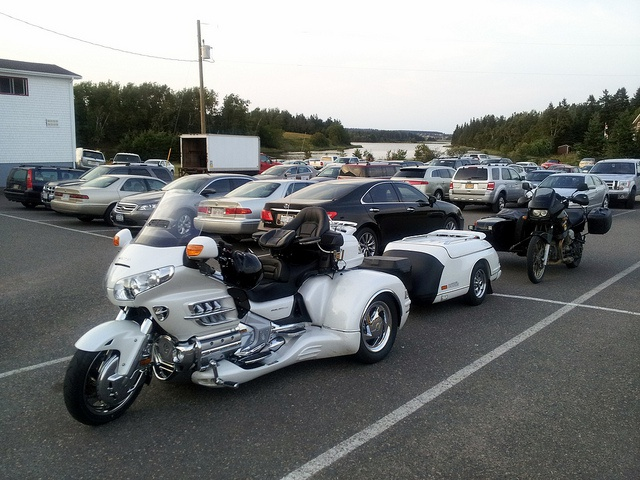Describe the objects in this image and their specific colors. I can see motorcycle in white, black, darkgray, lightgray, and gray tones, car in white, gray, black, and darkgray tones, car in white, black, gray, and darkgray tones, motorcycle in white, black, lightgray, darkgray, and gray tones, and motorcycle in white, black, gray, and darkgray tones in this image. 